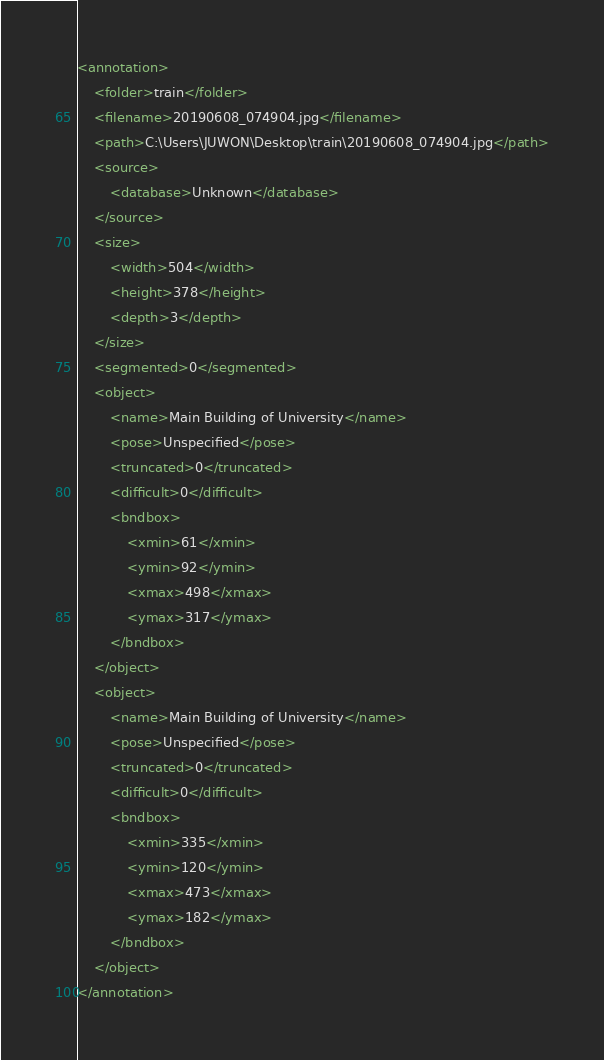Convert code to text. <code><loc_0><loc_0><loc_500><loc_500><_XML_><annotation>
	<folder>train</folder>
	<filename>20190608_074904.jpg</filename>
	<path>C:\Users\JUWON\Desktop\train\20190608_074904.jpg</path>
	<source>
		<database>Unknown</database>
	</source>
	<size>
		<width>504</width>
		<height>378</height>
		<depth>3</depth>
	</size>
	<segmented>0</segmented>
	<object>
		<name>Main Building of University</name>
		<pose>Unspecified</pose>
		<truncated>0</truncated>
		<difficult>0</difficult>
		<bndbox>
			<xmin>61</xmin>
			<ymin>92</ymin>
			<xmax>498</xmax>
			<ymax>317</ymax>
		</bndbox>
	</object>
	<object>
		<name>Main Building of University</name>
		<pose>Unspecified</pose>
		<truncated>0</truncated>
		<difficult>0</difficult>
		<bndbox>
			<xmin>335</xmin>
			<ymin>120</ymin>
			<xmax>473</xmax>
			<ymax>182</ymax>
		</bndbox>
	</object>
</annotation>
</code> 